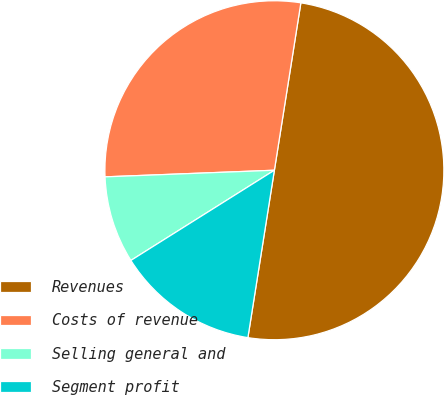<chart> <loc_0><loc_0><loc_500><loc_500><pie_chart><fcel>Revenues<fcel>Costs of revenue<fcel>Selling general and<fcel>Segment profit<nl><fcel>50.0%<fcel>28.12%<fcel>8.31%<fcel>13.57%<nl></chart> 